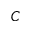Convert formula to latex. <formula><loc_0><loc_0><loc_500><loc_500>C</formula> 